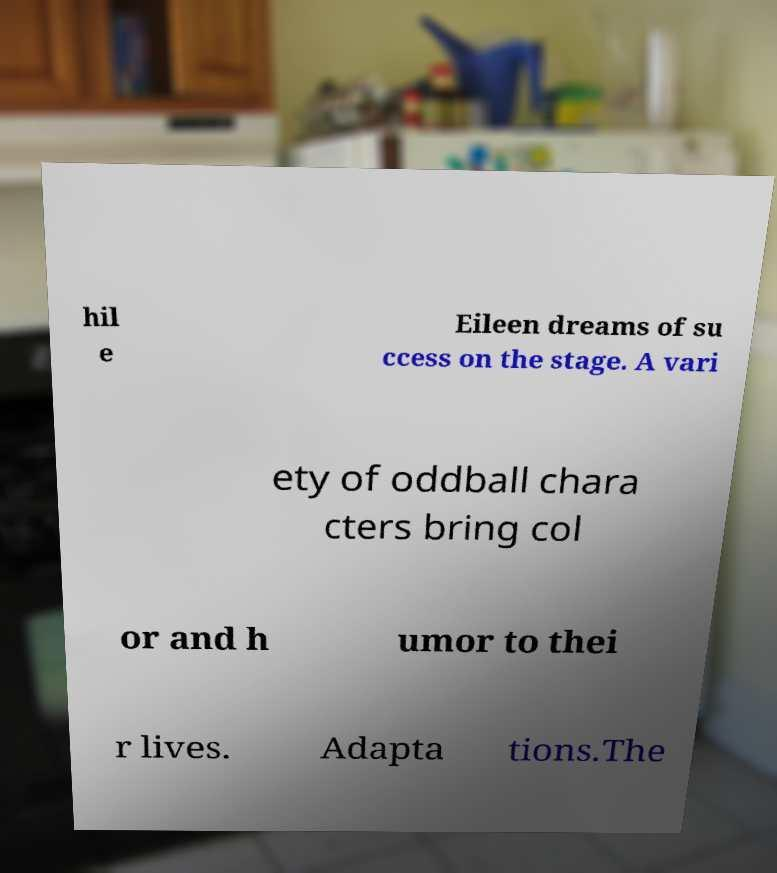Can you read and provide the text displayed in the image?This photo seems to have some interesting text. Can you extract and type it out for me? hil e Eileen dreams of su ccess on the stage. A vari ety of oddball chara cters bring col or and h umor to thei r lives. Adapta tions.The 